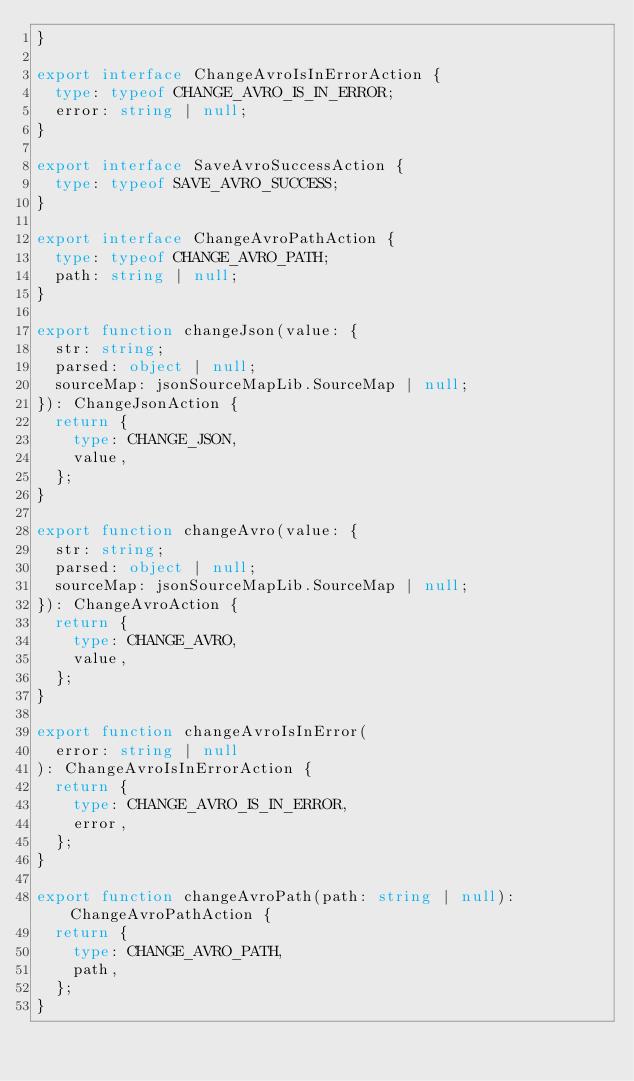<code> <loc_0><loc_0><loc_500><loc_500><_TypeScript_>}

export interface ChangeAvroIsInErrorAction {
  type: typeof CHANGE_AVRO_IS_IN_ERROR;
  error: string | null;
}

export interface SaveAvroSuccessAction {
  type: typeof SAVE_AVRO_SUCCESS;
}

export interface ChangeAvroPathAction {
  type: typeof CHANGE_AVRO_PATH;
  path: string | null;
}

export function changeJson(value: {
  str: string;
  parsed: object | null;
  sourceMap: jsonSourceMapLib.SourceMap | null;
}): ChangeJsonAction {
  return {
    type: CHANGE_JSON,
    value,
  };
}

export function changeAvro(value: {
  str: string;
  parsed: object | null;
  sourceMap: jsonSourceMapLib.SourceMap | null;
}): ChangeAvroAction {
  return {
    type: CHANGE_AVRO,
    value,
  };
}

export function changeAvroIsInError(
  error: string | null
): ChangeAvroIsInErrorAction {
  return {
    type: CHANGE_AVRO_IS_IN_ERROR,
    error,
  };
}

export function changeAvroPath(path: string | null): ChangeAvroPathAction {
  return {
    type: CHANGE_AVRO_PATH,
    path,
  };
}
</code> 